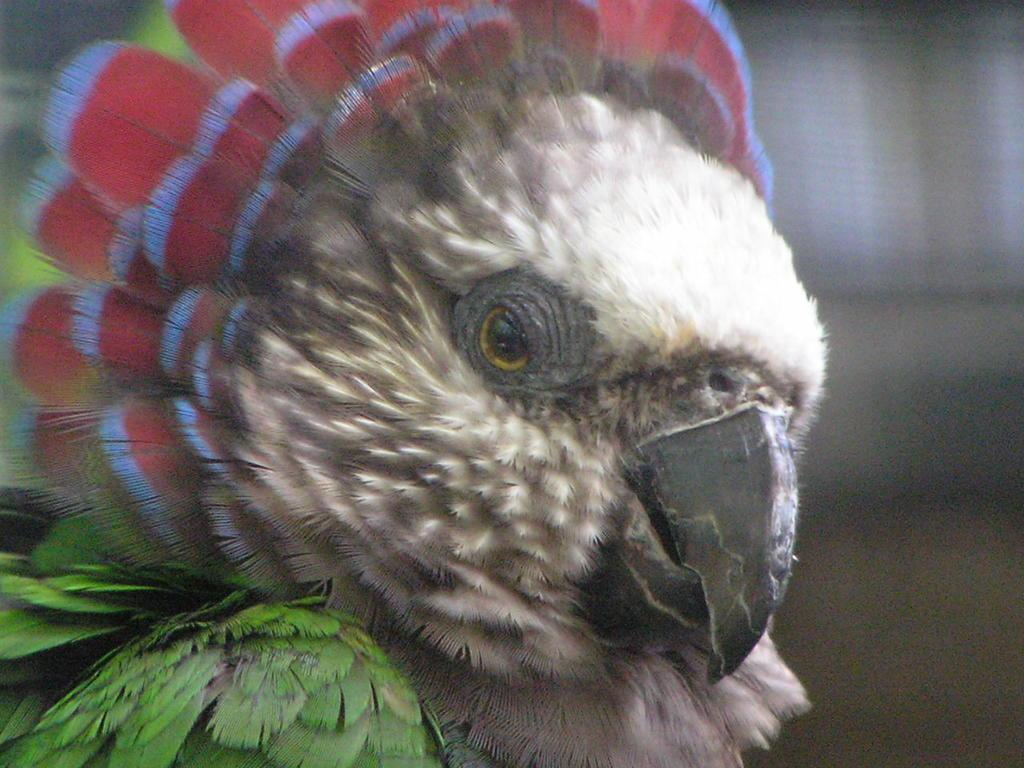What type of animal is in the image? There is a parrot in the image. Can you describe the background of the image? The background of the image is blurred. Where is the faucet located in the image? There is no faucet present in the image; it only features a parrot. What nation is represented by the parrot in the image? The image does not represent any specific nation; it simply features a parrot. 